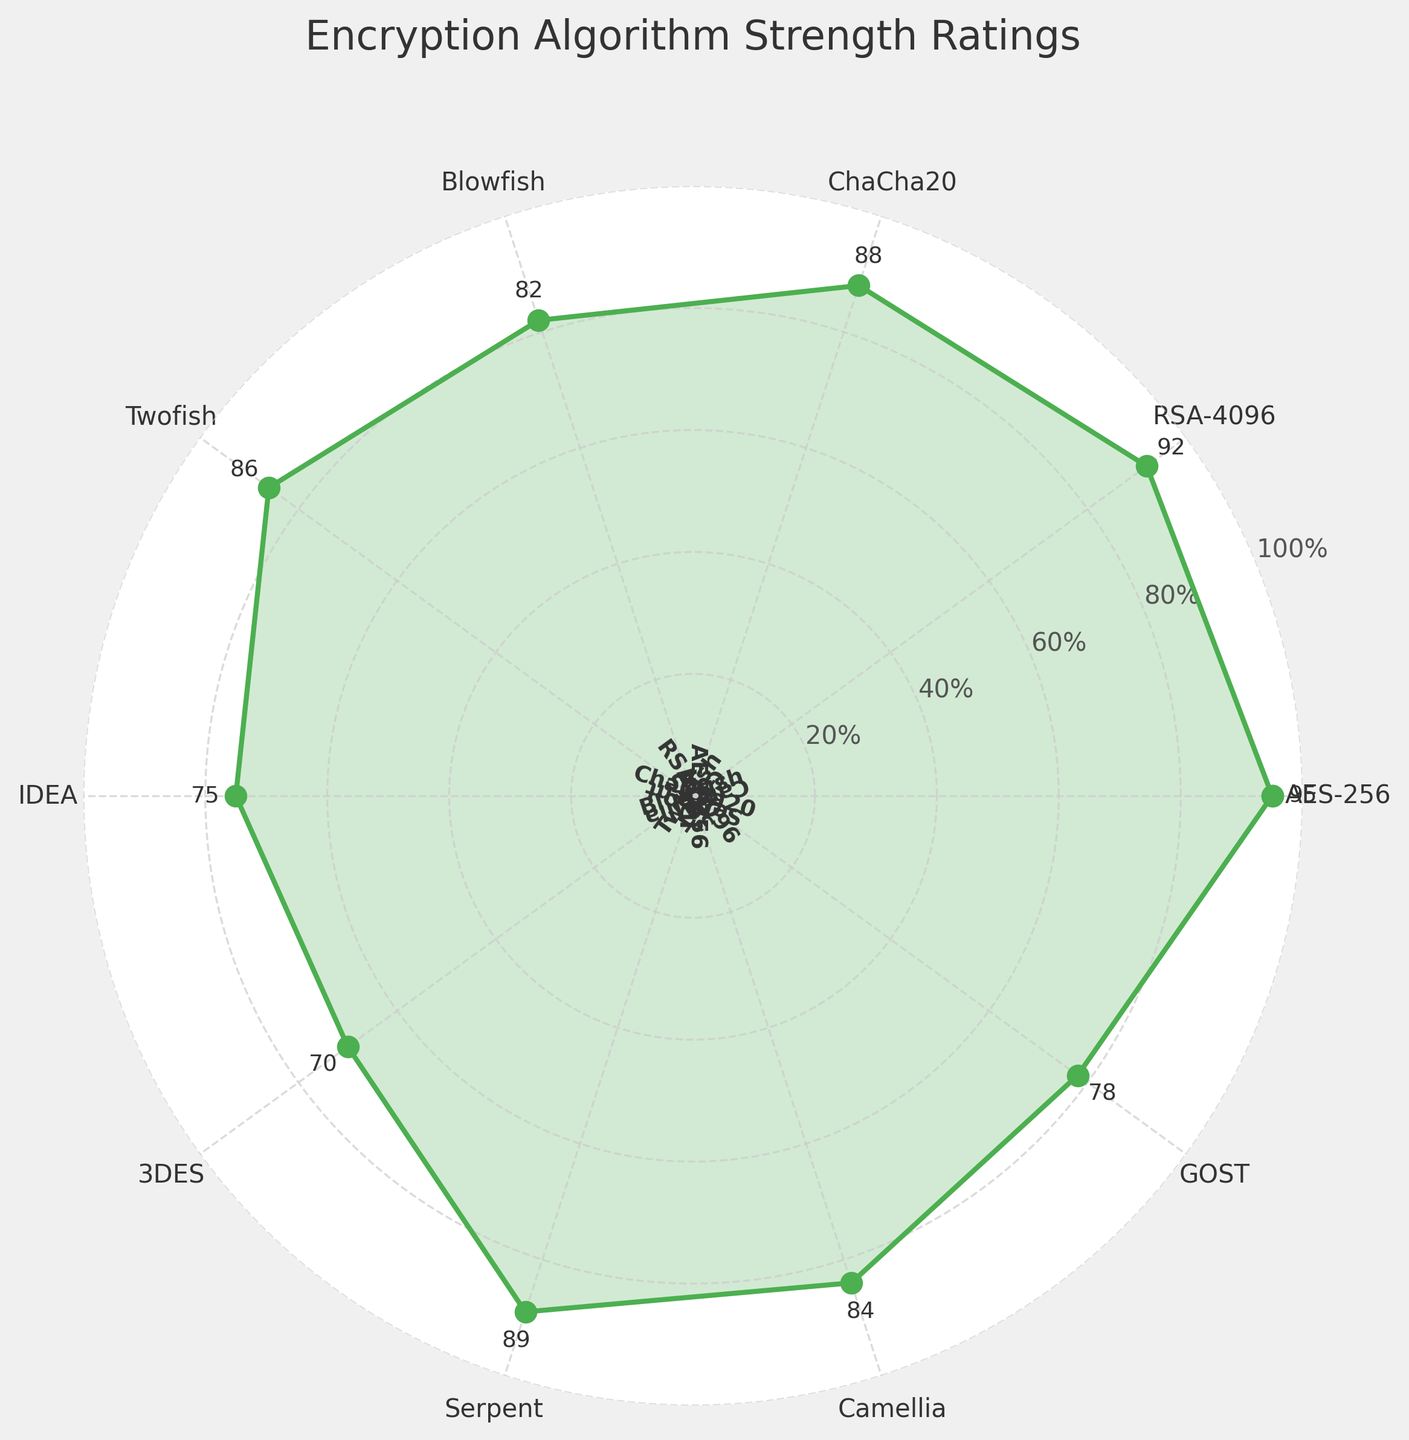What encryption algorithm has the highest strength rating? The figure shows ratings for several algorithms. The highest rating is 95, which corresponds to AES-256.
Answer: AES-256 How many algorithms have a strength rating of 80 or higher? The figure plots the ratings for each algorithm. Those with ratings of 80 or higher are AES-256, RSA-4096, ChaCha20, Blowfish, Twofish, Serpent, and Camellia, totaling seven.
Answer: 7 Which algorithm has the lowest strength rating? By examining each plotted point’s rating, the lowest rating is 70, which corresponds to 3DES.
Answer: 3DES What's the average strength rating for all the algorithms shown? Summing all ratings: 95 (AES-256) + 92 (RSA-4096) + 88 (ChaCha20) + 82 (Blowfish) + 86 (Twofish) + 75 (IDEA) + 70 (3DES) + 89 (Serpent) + 84 (Camellia) + 78 (GOST) = 839. Dividing by 10 algorithms results in an average rating of 83.9.
Answer: 83.9 How much higher is the strength rating of AES-256 compared to 3DES? The rating for AES-256 is 95 and for 3DES is 70. Subtraction gives 95 - 70 = 25.
Answer: 25 Which algorithm is rated lower: Blowfish or Camellia? The figure shows Blowfish with a rating of 82 and Camellia with 84, so Blowfish is rated lower.
Answer: Blowfish Is the strength rating of RSA-4096 higher than Serpent? RSA-4096 has a rating of 92 and Serpent has a rating of 89, so RSA-4096 is higher.
Answer: Yes What's the difference between the highest and the lowest strength ratings? The highest rating is 95 (AES-256) and the lowest is 70 (3DES). The difference is 95 - 70, which equals 25.
Answer: 25 Which two algorithms have the closest strength ratings and what are these ratings? By examining the ratings, Camellia (84) and Blowfish (82) have the smallest difference of 2 between their ratings.
Answer: Camellia and Blowfish (84 and 82) Is the average rating of ChaCha20, Blowfish, and Twofish higher or lower than IDEA's rating? ChaCha20 (88) + Blowfish (82) + Twofish (86) equals 256. The average is 256/3 = about 85.3. IDEA's rating is 75, so the average is higher.
Answer: Higher 